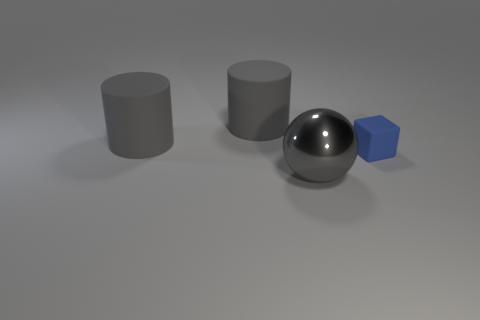Add 1 small rubber cubes. How many objects exist? 5 Subtract all rubber cubes. Subtract all tiny brown shiny blocks. How many objects are left? 3 Add 2 tiny blue rubber cubes. How many tiny blue rubber cubes are left? 3 Add 4 large shiny spheres. How many large shiny spheres exist? 5 Subtract 0 brown cylinders. How many objects are left? 4 